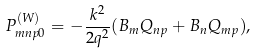Convert formula to latex. <formula><loc_0><loc_0><loc_500><loc_500>P ^ { ( W ) } _ { m n p 0 } = - \frac { k ^ { 2 } } { 2 q ^ { 2 } } ( B _ { m } Q _ { n p } + B _ { n } Q _ { m p } ) ,</formula> 